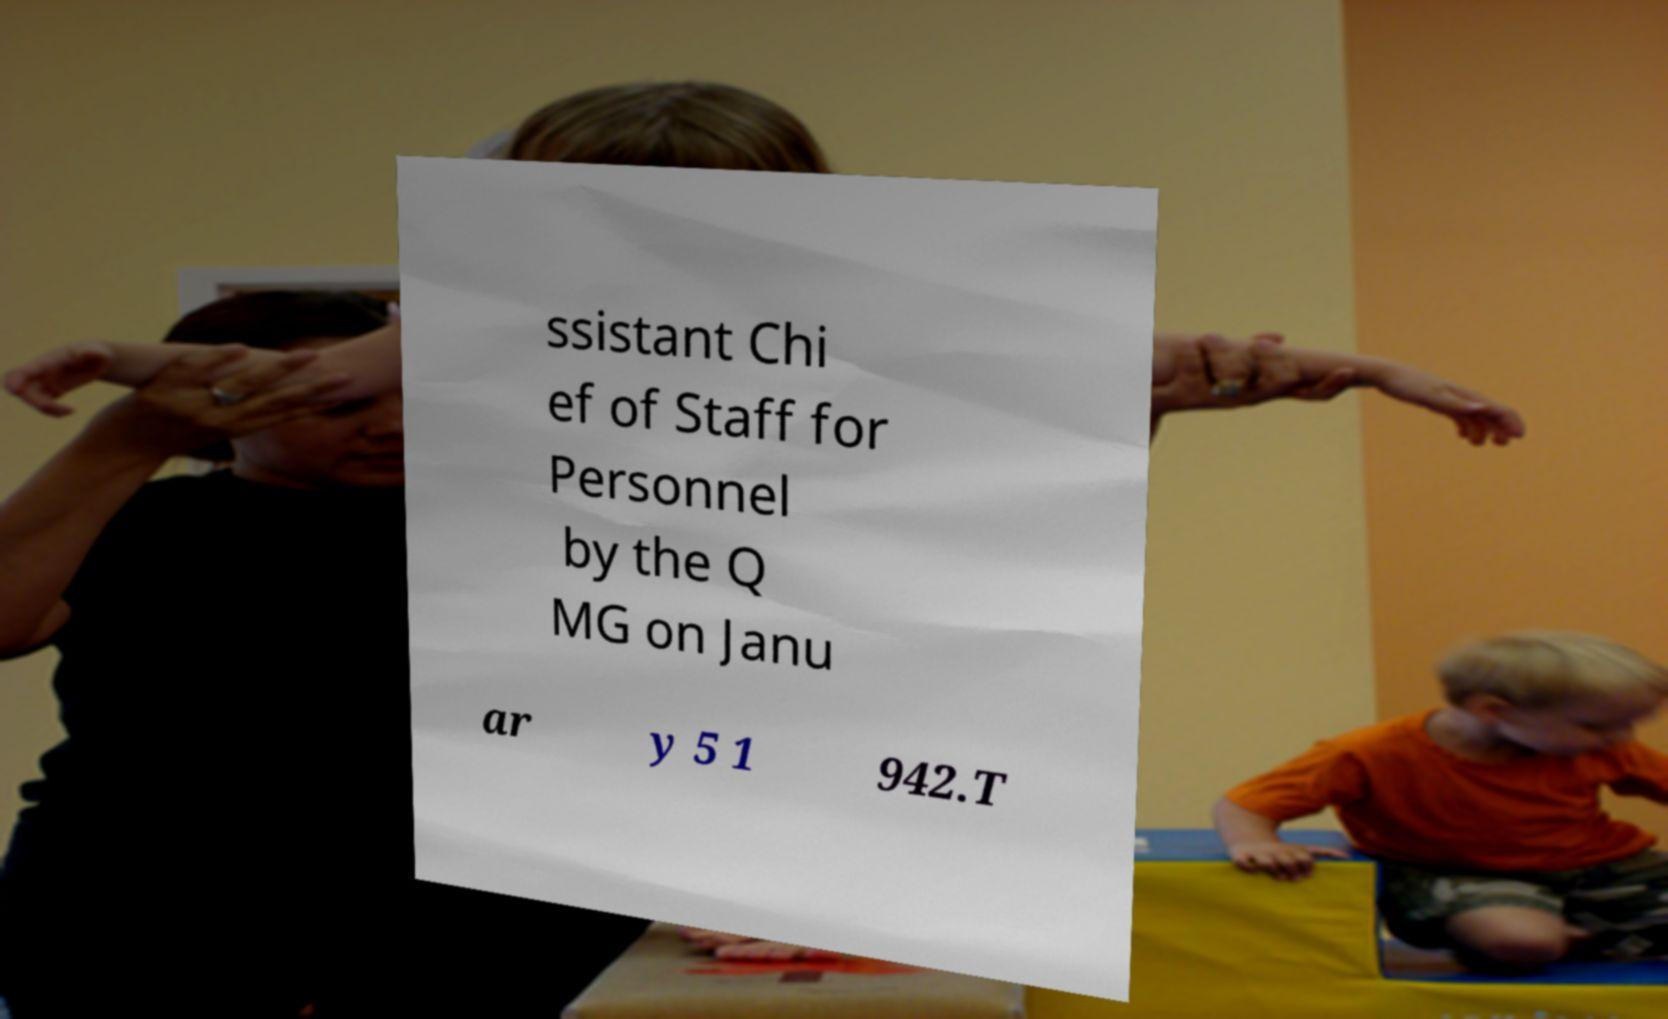Can you accurately transcribe the text from the provided image for me? ssistant Chi ef of Staff for Personnel by the Q MG on Janu ar y 5 1 942.T 